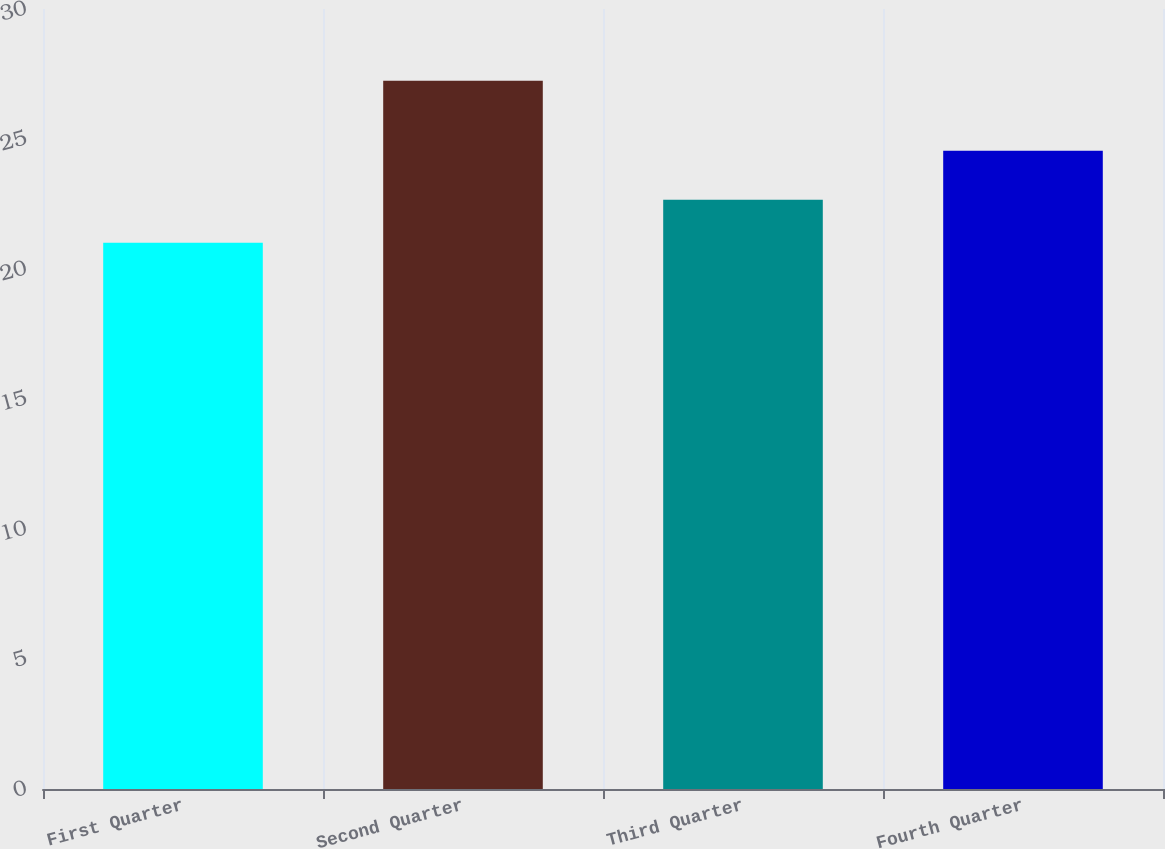<chart> <loc_0><loc_0><loc_500><loc_500><bar_chart><fcel>First Quarter<fcel>Second Quarter<fcel>Third Quarter<fcel>Fourth Quarter<nl><fcel>21.01<fcel>27.24<fcel>22.66<fcel>24.55<nl></chart> 